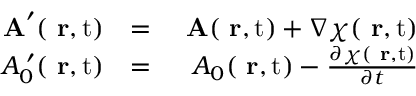<formula> <loc_0><loc_0><loc_500><loc_500>\begin{array} { r l r } { A ^ { \prime } ( { r } , t ) } & { = } & { A ( { r } , t ) + \nabla \chi ( { r } , t ) } \\ { A _ { 0 } ^ { \, \prime } ( { r } , t ) } & { = } & { A _ { 0 } ( { r } , t ) - \frac { \partial \chi ( { r } , t ) } { \partial t } } \end{array}</formula> 